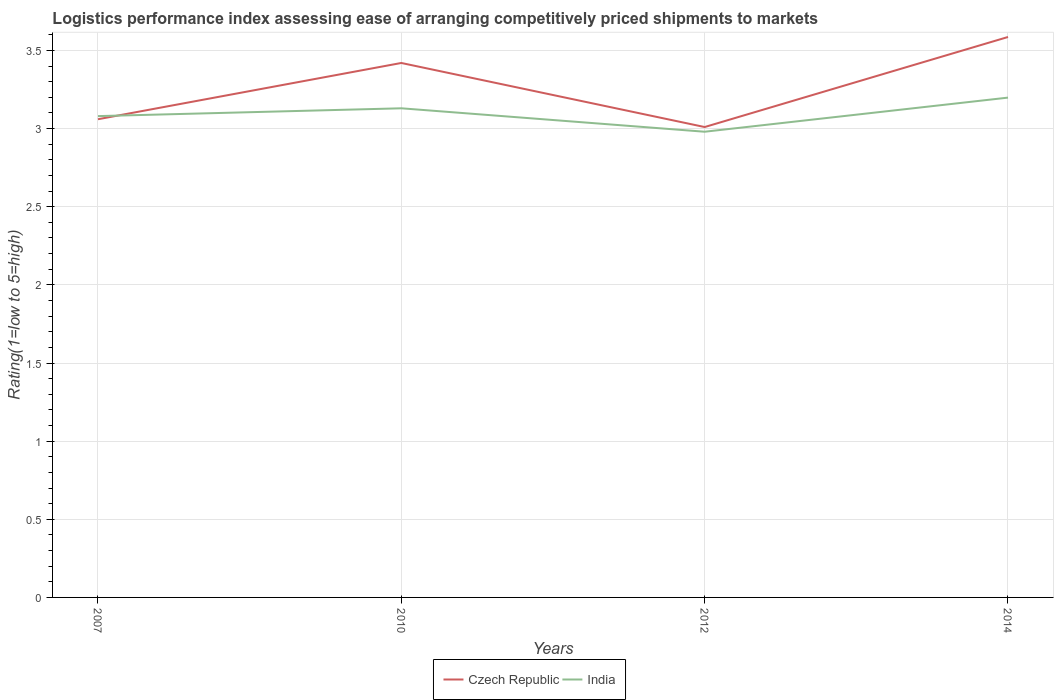Is the number of lines equal to the number of legend labels?
Give a very brief answer. Yes. Across all years, what is the maximum Logistic performance index in India?
Your response must be concise. 2.98. What is the total Logistic performance index in Czech Republic in the graph?
Provide a succinct answer. -0.58. What is the difference between the highest and the second highest Logistic performance index in India?
Offer a very short reply. 0.22. Is the Logistic performance index in India strictly greater than the Logistic performance index in Czech Republic over the years?
Provide a succinct answer. No. How many years are there in the graph?
Make the answer very short. 4. Are the values on the major ticks of Y-axis written in scientific E-notation?
Your response must be concise. No. Does the graph contain any zero values?
Offer a very short reply. No. Does the graph contain grids?
Ensure brevity in your answer.  Yes. What is the title of the graph?
Your answer should be very brief. Logistics performance index assessing ease of arranging competitively priced shipments to markets. What is the label or title of the Y-axis?
Offer a very short reply. Rating(1=low to 5=high). What is the Rating(1=low to 5=high) in Czech Republic in 2007?
Offer a very short reply. 3.06. What is the Rating(1=low to 5=high) in India in 2007?
Provide a succinct answer. 3.08. What is the Rating(1=low to 5=high) in Czech Republic in 2010?
Make the answer very short. 3.42. What is the Rating(1=low to 5=high) of India in 2010?
Ensure brevity in your answer.  3.13. What is the Rating(1=low to 5=high) of Czech Republic in 2012?
Offer a very short reply. 3.01. What is the Rating(1=low to 5=high) in India in 2012?
Ensure brevity in your answer.  2.98. What is the Rating(1=low to 5=high) in Czech Republic in 2014?
Make the answer very short. 3.59. What is the Rating(1=low to 5=high) in India in 2014?
Offer a very short reply. 3.2. Across all years, what is the maximum Rating(1=low to 5=high) of Czech Republic?
Offer a terse response. 3.59. Across all years, what is the maximum Rating(1=low to 5=high) of India?
Provide a short and direct response. 3.2. Across all years, what is the minimum Rating(1=low to 5=high) of Czech Republic?
Ensure brevity in your answer.  3.01. Across all years, what is the minimum Rating(1=low to 5=high) of India?
Offer a very short reply. 2.98. What is the total Rating(1=low to 5=high) of Czech Republic in the graph?
Offer a terse response. 13.08. What is the total Rating(1=low to 5=high) in India in the graph?
Your answer should be very brief. 12.39. What is the difference between the Rating(1=low to 5=high) in Czech Republic in 2007 and that in 2010?
Offer a very short reply. -0.36. What is the difference between the Rating(1=low to 5=high) of Czech Republic in 2007 and that in 2014?
Offer a terse response. -0.53. What is the difference between the Rating(1=low to 5=high) of India in 2007 and that in 2014?
Make the answer very short. -0.12. What is the difference between the Rating(1=low to 5=high) in Czech Republic in 2010 and that in 2012?
Give a very brief answer. 0.41. What is the difference between the Rating(1=low to 5=high) of India in 2010 and that in 2012?
Offer a very short reply. 0.15. What is the difference between the Rating(1=low to 5=high) of Czech Republic in 2010 and that in 2014?
Your response must be concise. -0.17. What is the difference between the Rating(1=low to 5=high) in India in 2010 and that in 2014?
Your response must be concise. -0.07. What is the difference between the Rating(1=low to 5=high) in Czech Republic in 2012 and that in 2014?
Offer a very short reply. -0.58. What is the difference between the Rating(1=low to 5=high) of India in 2012 and that in 2014?
Provide a succinct answer. -0.22. What is the difference between the Rating(1=low to 5=high) in Czech Republic in 2007 and the Rating(1=low to 5=high) in India in 2010?
Give a very brief answer. -0.07. What is the difference between the Rating(1=low to 5=high) in Czech Republic in 2007 and the Rating(1=low to 5=high) in India in 2012?
Your answer should be very brief. 0.08. What is the difference between the Rating(1=low to 5=high) in Czech Republic in 2007 and the Rating(1=low to 5=high) in India in 2014?
Offer a terse response. -0.14. What is the difference between the Rating(1=low to 5=high) in Czech Republic in 2010 and the Rating(1=low to 5=high) in India in 2012?
Make the answer very short. 0.44. What is the difference between the Rating(1=low to 5=high) of Czech Republic in 2010 and the Rating(1=low to 5=high) of India in 2014?
Your response must be concise. 0.22. What is the difference between the Rating(1=low to 5=high) in Czech Republic in 2012 and the Rating(1=low to 5=high) in India in 2014?
Your response must be concise. -0.19. What is the average Rating(1=low to 5=high) of Czech Republic per year?
Offer a terse response. 3.27. What is the average Rating(1=low to 5=high) in India per year?
Offer a very short reply. 3.1. In the year 2007, what is the difference between the Rating(1=low to 5=high) in Czech Republic and Rating(1=low to 5=high) in India?
Make the answer very short. -0.02. In the year 2010, what is the difference between the Rating(1=low to 5=high) of Czech Republic and Rating(1=low to 5=high) of India?
Keep it short and to the point. 0.29. In the year 2012, what is the difference between the Rating(1=low to 5=high) in Czech Republic and Rating(1=low to 5=high) in India?
Keep it short and to the point. 0.03. In the year 2014, what is the difference between the Rating(1=low to 5=high) in Czech Republic and Rating(1=low to 5=high) in India?
Your answer should be very brief. 0.39. What is the ratio of the Rating(1=low to 5=high) of Czech Republic in 2007 to that in 2010?
Keep it short and to the point. 0.89. What is the ratio of the Rating(1=low to 5=high) in India in 2007 to that in 2010?
Your response must be concise. 0.98. What is the ratio of the Rating(1=low to 5=high) of Czech Republic in 2007 to that in 2012?
Offer a very short reply. 1.02. What is the ratio of the Rating(1=low to 5=high) in India in 2007 to that in 2012?
Your answer should be compact. 1.03. What is the ratio of the Rating(1=low to 5=high) of Czech Republic in 2007 to that in 2014?
Give a very brief answer. 0.85. What is the ratio of the Rating(1=low to 5=high) of India in 2007 to that in 2014?
Your response must be concise. 0.96. What is the ratio of the Rating(1=low to 5=high) of Czech Republic in 2010 to that in 2012?
Keep it short and to the point. 1.14. What is the ratio of the Rating(1=low to 5=high) of India in 2010 to that in 2012?
Offer a very short reply. 1.05. What is the ratio of the Rating(1=low to 5=high) in Czech Republic in 2010 to that in 2014?
Your answer should be very brief. 0.95. What is the ratio of the Rating(1=low to 5=high) of India in 2010 to that in 2014?
Make the answer very short. 0.98. What is the ratio of the Rating(1=low to 5=high) in Czech Republic in 2012 to that in 2014?
Make the answer very short. 0.84. What is the ratio of the Rating(1=low to 5=high) of India in 2012 to that in 2014?
Keep it short and to the point. 0.93. What is the difference between the highest and the second highest Rating(1=low to 5=high) of Czech Republic?
Your response must be concise. 0.17. What is the difference between the highest and the second highest Rating(1=low to 5=high) in India?
Make the answer very short. 0.07. What is the difference between the highest and the lowest Rating(1=low to 5=high) of Czech Republic?
Make the answer very short. 0.58. What is the difference between the highest and the lowest Rating(1=low to 5=high) in India?
Provide a succinct answer. 0.22. 